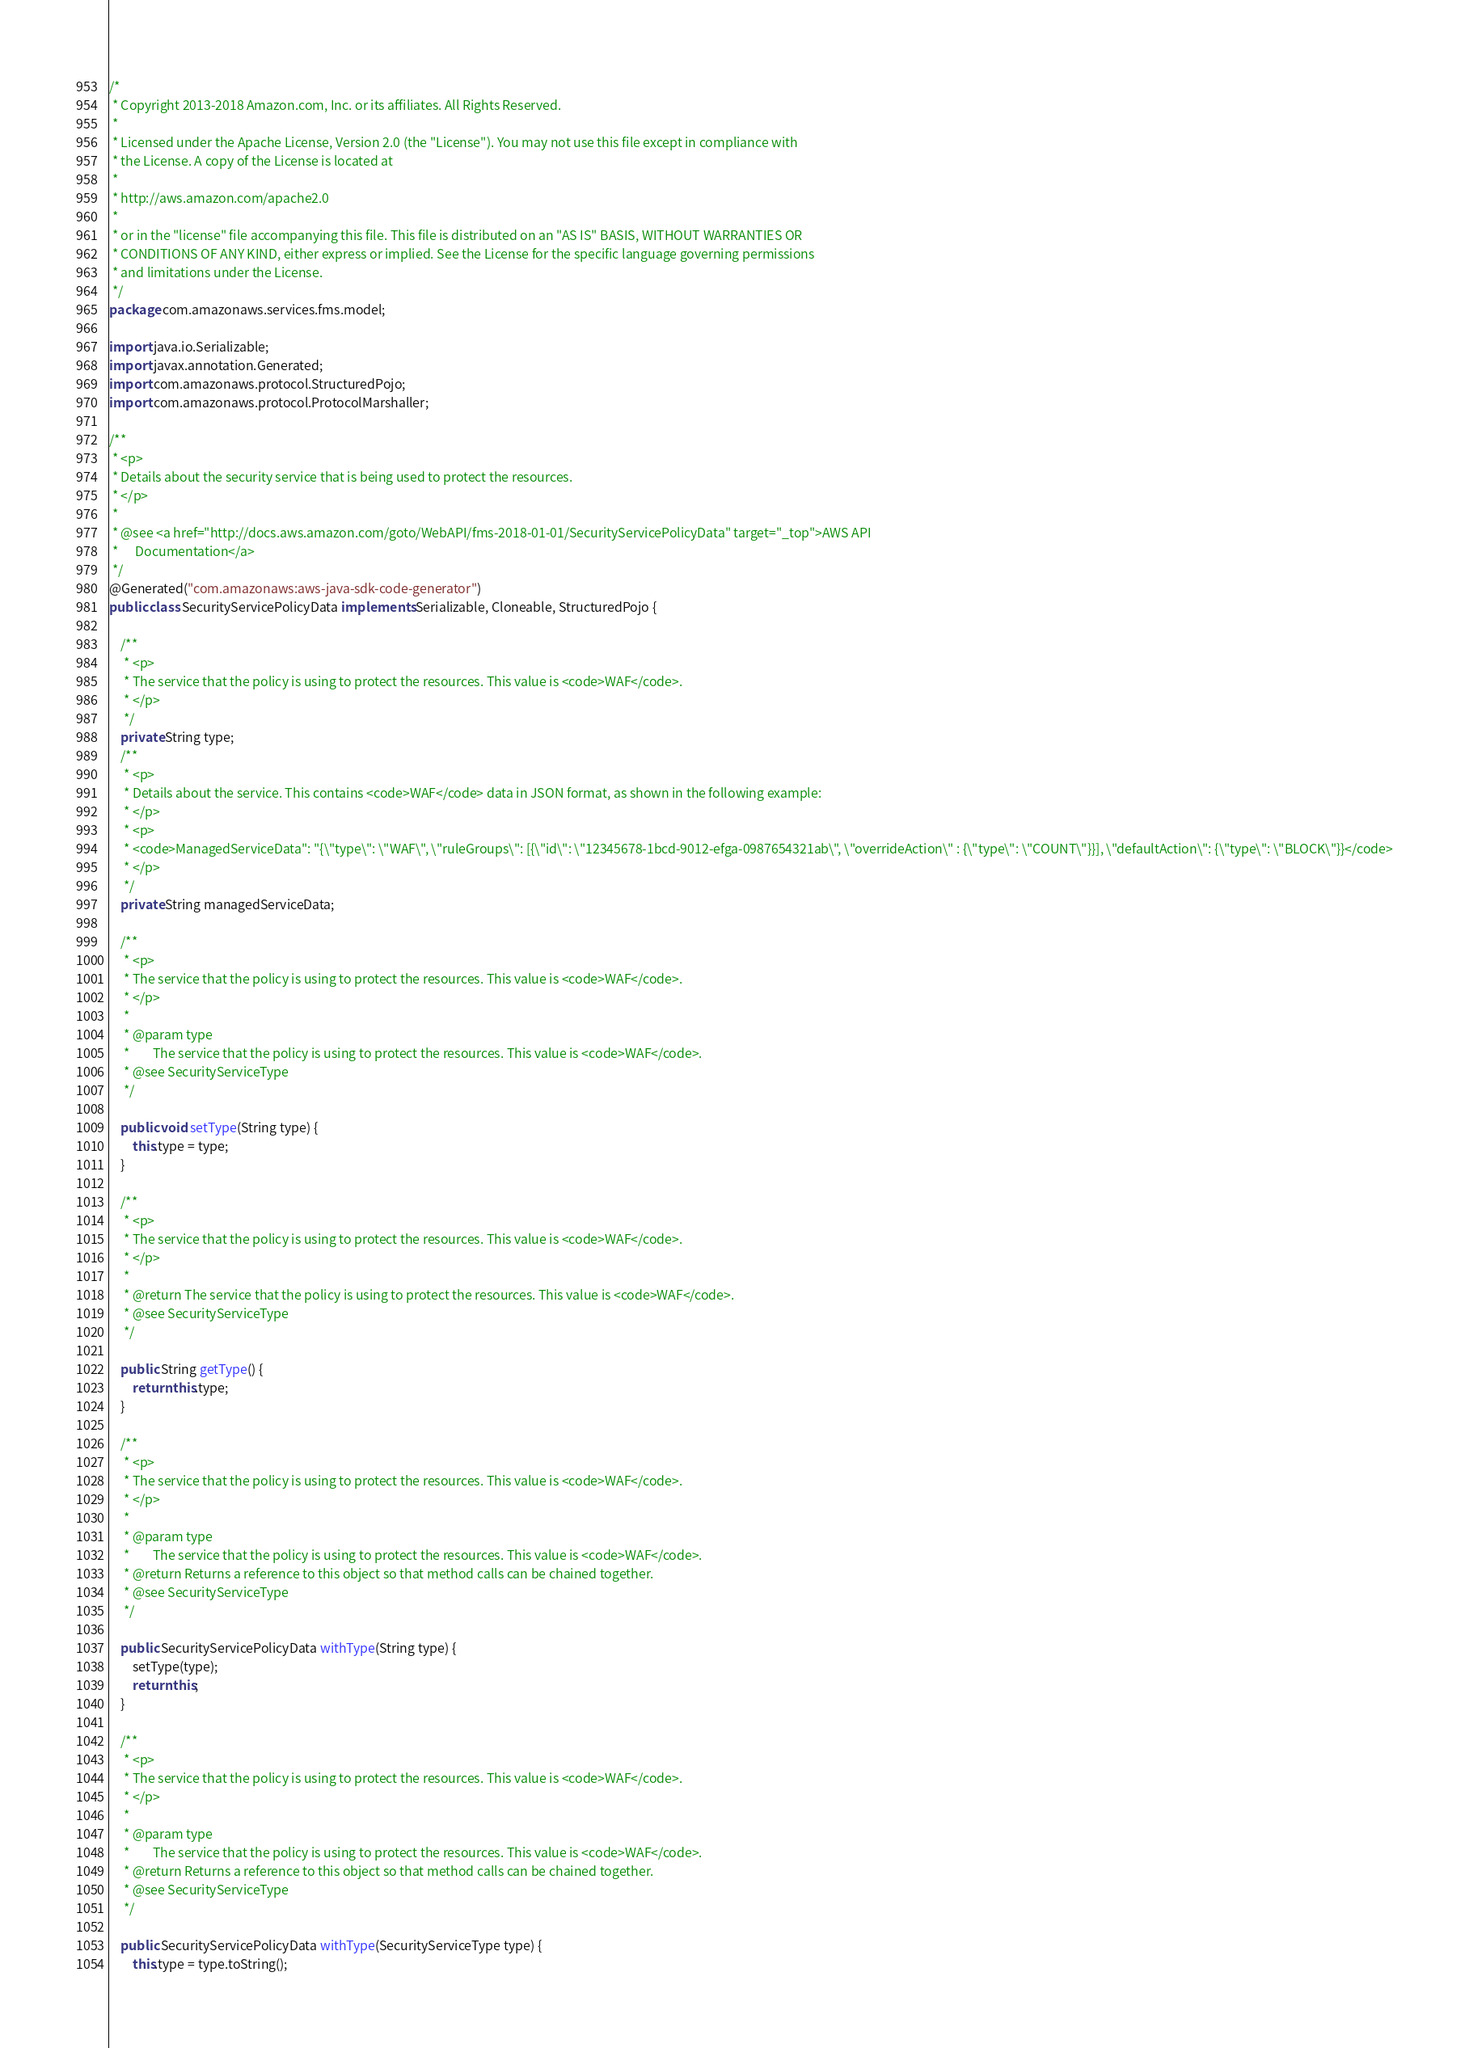Convert code to text. <code><loc_0><loc_0><loc_500><loc_500><_Java_>/*
 * Copyright 2013-2018 Amazon.com, Inc. or its affiliates. All Rights Reserved.
 * 
 * Licensed under the Apache License, Version 2.0 (the "License"). You may not use this file except in compliance with
 * the License. A copy of the License is located at
 * 
 * http://aws.amazon.com/apache2.0
 * 
 * or in the "license" file accompanying this file. This file is distributed on an "AS IS" BASIS, WITHOUT WARRANTIES OR
 * CONDITIONS OF ANY KIND, either express or implied. See the License for the specific language governing permissions
 * and limitations under the License.
 */
package com.amazonaws.services.fms.model;

import java.io.Serializable;
import javax.annotation.Generated;
import com.amazonaws.protocol.StructuredPojo;
import com.amazonaws.protocol.ProtocolMarshaller;

/**
 * <p>
 * Details about the security service that is being used to protect the resources.
 * </p>
 * 
 * @see <a href="http://docs.aws.amazon.com/goto/WebAPI/fms-2018-01-01/SecurityServicePolicyData" target="_top">AWS API
 *      Documentation</a>
 */
@Generated("com.amazonaws:aws-java-sdk-code-generator")
public class SecurityServicePolicyData implements Serializable, Cloneable, StructuredPojo {

    /**
     * <p>
     * The service that the policy is using to protect the resources. This value is <code>WAF</code>.
     * </p>
     */
    private String type;
    /**
     * <p>
     * Details about the service. This contains <code>WAF</code> data in JSON format, as shown in the following example:
     * </p>
     * <p>
     * <code>ManagedServiceData": "{\"type\": \"WAF\", \"ruleGroups\": [{\"id\": \"12345678-1bcd-9012-efga-0987654321ab\", \"overrideAction\" : {\"type\": \"COUNT\"}}], \"defaultAction\": {\"type\": \"BLOCK\"}}</code>
     * </p>
     */
    private String managedServiceData;

    /**
     * <p>
     * The service that the policy is using to protect the resources. This value is <code>WAF</code>.
     * </p>
     * 
     * @param type
     *        The service that the policy is using to protect the resources. This value is <code>WAF</code>.
     * @see SecurityServiceType
     */

    public void setType(String type) {
        this.type = type;
    }

    /**
     * <p>
     * The service that the policy is using to protect the resources. This value is <code>WAF</code>.
     * </p>
     * 
     * @return The service that the policy is using to protect the resources. This value is <code>WAF</code>.
     * @see SecurityServiceType
     */

    public String getType() {
        return this.type;
    }

    /**
     * <p>
     * The service that the policy is using to protect the resources. This value is <code>WAF</code>.
     * </p>
     * 
     * @param type
     *        The service that the policy is using to protect the resources. This value is <code>WAF</code>.
     * @return Returns a reference to this object so that method calls can be chained together.
     * @see SecurityServiceType
     */

    public SecurityServicePolicyData withType(String type) {
        setType(type);
        return this;
    }

    /**
     * <p>
     * The service that the policy is using to protect the resources. This value is <code>WAF</code>.
     * </p>
     * 
     * @param type
     *        The service that the policy is using to protect the resources. This value is <code>WAF</code>.
     * @return Returns a reference to this object so that method calls can be chained together.
     * @see SecurityServiceType
     */

    public SecurityServicePolicyData withType(SecurityServiceType type) {
        this.type = type.toString();</code> 